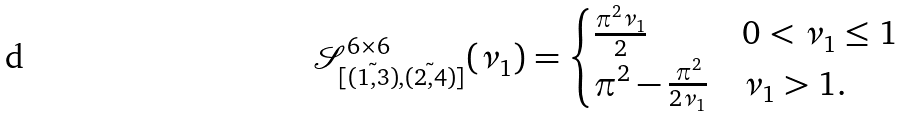Convert formula to latex. <formula><loc_0><loc_0><loc_500><loc_500>\mathcal { S } _ { [ \tilde { ( 1 , 3 ) } , \tilde { ( 2 , 4 ) } ] } ^ { 6 \times 6 } ( \nu _ { 1 } ) = \begin{cases} \frac { \pi ^ { 2 } \nu _ { 1 } } { 2 } & 0 < \nu _ { 1 } \leq 1 \\ \pi ^ { 2 } - \frac { \pi ^ { 2 } } { 2 \nu _ { 1 } } & \nu _ { 1 } > 1 . \end{cases}</formula> 